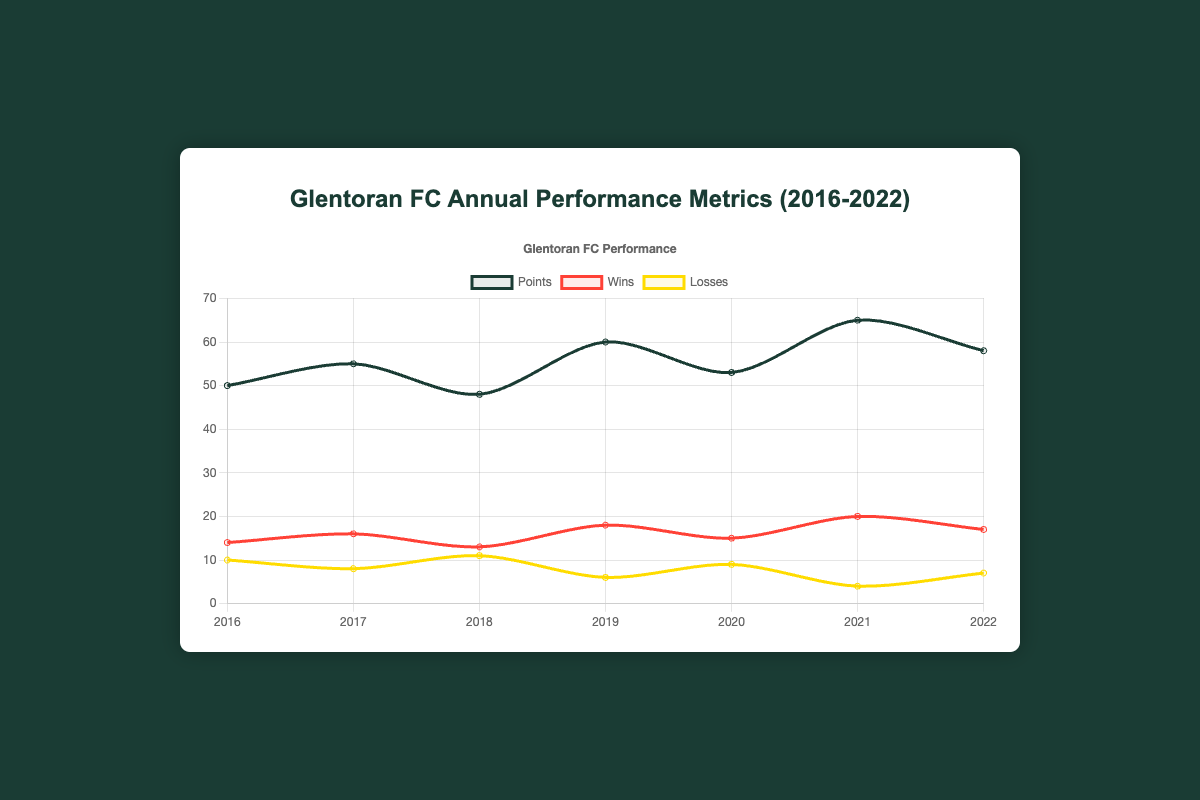Which year did Glentoran FC achieve the highest points? The line chart indicates that the highest points were achieved in 2021, with the 'Points' line peaking at 65.
Answer: 2021 In which year did Glentoran FC have the fewest wins? The 'Wins' line shows the lowest point in 2018, where it dropped to 13.
Answer: 2018 How many points did Glentoran FC score on average from 2016 to 2022? Sum the points for each year (50 + 55 + 48 + 60 + 53 + 65 + 58 = 389) and divide by the number of years (7). Average = 389 / 7 = 55.57
Answer: 55.57 Which year saw the largest difference between wins and losses for Glentoran FC? Calculate the difference between wins and losses for each year and identify the largest: 
2016: 14-10=4, 
2017: 16-8=8, 
2018: 13-11=2,
2019: 18-6=12,
2020: 15-9=6,
2021: 20-4=16,
2022: 17-7=10. The largest difference is in 2021, with a difference of 16.
Answer: 2021 Did Glentoran FC have more wins or losses in 2017? By how much? In 2017, they had 16 wins and 8 losses. The difference is calculated as 16 - 8 = 8.
Answer: More wins by 8 Compare the trend of the 'Points' line and the 'Wins' line from 2019 to 2021. What do you observe? From 2019 to 2021, both 'Points' and 'Wins' lines display an increasing trend. Points increased from 60 to 65, and Wins increased from 18 to 20.
Answer: Increasing trend Is there any year in which Glentoran FC had the same amount of wins and losses? By comparing the 'Wins' and 'Losses' lines for each year, it is clear that no year had the same amount of wins and losses.
Answer: No Between 2020 and 2021, did the number of losses increase or decrease, and by how much? The 'Losses' line shows that it decreased from 9 in 2020 to 4 in 2021, a difference of 5.
Answer: Decreased by 5 What color is used to represent the 'Losses' data in the chart? The 'Losses' line is depicted in yellow.
Answer: Yellow 